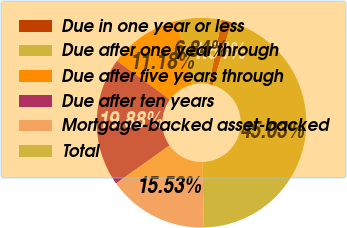<chart> <loc_0><loc_0><loc_500><loc_500><pie_chart><fcel>Due in one year or less<fcel>Due after one year through<fcel>Due after five years through<fcel>Due after ten years<fcel>Mortgage-backed asset-backed<fcel>Total<nl><fcel>1.54%<fcel>6.84%<fcel>11.18%<fcel>19.88%<fcel>15.53%<fcel>45.03%<nl></chart> 